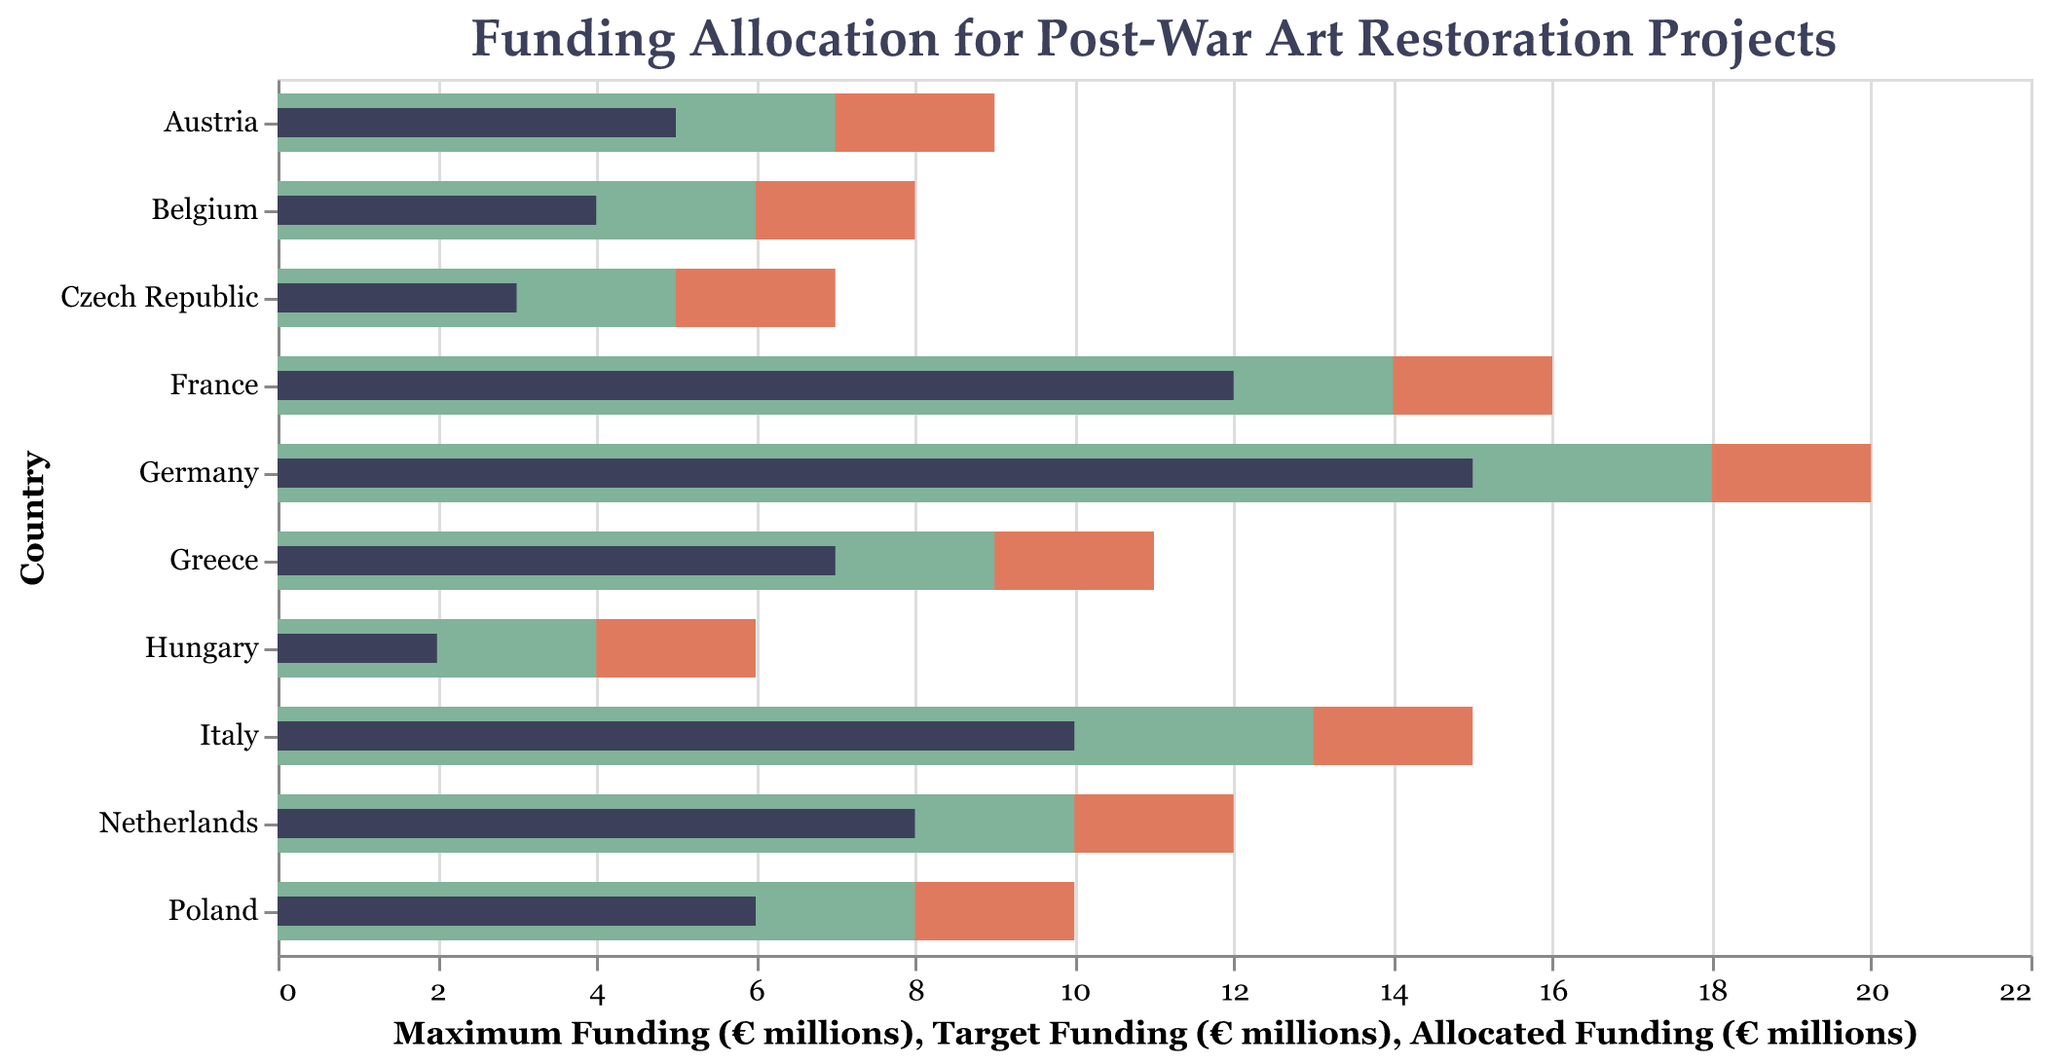What's the highest amount of allocated funding and which country has it? The highest amount of allocated funding can be found by identifying the maximum value in the "Allocated Funding" column. Germany has the highest allocated funding amounting to €15 million.
Answer: Germany, €15 million Comparing Germany and France, which country has a closer allocated funding amount to its target funding? Germany's allocated funding is €15 million and its target funding is €18 million, whereas France's allocated funding is €12 million and its target funding is €14 million. We calculate the difference for both: Germany's difference is €3 million, and France's difference is €2 million. France has allocated funding closer to its target funding.
Answer: France Which country has the largest difference between its allocated and maximum funding? To find the largest difference, subtract the allocated funding from the maximum funding for each country. The country with the largest difference will be identified. Germany: €20M - €15M = €5M, France: €16M - €12M = €4M, Italy: €15M - €10M = €5M, Netherlands: €12M - €8M = €4M, Poland: €10M - €6M = €4M, Austria: €9M - €5M = €4M, Belgium: €8M - €4M = €4M, Czech Republic: €7M - €3M = €4M, Hungary: €6M - €2M = €4M, Greece: €11M - €7M = €4M. Both Germany and Italy have the largest difference of €5 million.
Answer: Germany and Italy What's the median allocated funding value across all countries? To find the median, list all the allocated funding values and find the middle value. The allocated funding values are €15M, €12M, €10M, €8M, €6M, €5M, €4M, €3M, €2M, and €7M. Ordering these values: €2M, €3M, €4M, €5M, €6M, €7M, €8M, €10M, €12M, €15M. The median is the average of the 5th and 6th values: (€6M + €7M) / 2 = €6.5M.
Answer: €6.5 million Which two countries meet their target funding most closely? To determine which countries meet their target funding most closely, calculate the differences between allocated funding and target funding for each. Smaller differences indicate closer alignment. Germany: €3M, France: €2M, Italy: €3M, Netherlands: €2M, Poland: €2M, Austria: €2M, Belgium: €2M, Czech Republic: €2M, Hungary: €2M, Greece: €2M. France and Italy each have a difference of €2 million. Unless further precision is needed, multiple countries tie, but for primary identification, France and Netherlands are examples.
Answer: France and Netherlands Which country has allocated funding furthest from its target funding? By examining the differences between allocated funding and target funding, we identify: Germany: €3M, France: €2M, Italy: €3M, Netherlands: €2M, Poland: €2M, Austria: €2M, Belgium: €2M, Czech Republic: €2M, Hungary: €2M, Greece: €2M. Given the uniformity, Germany and Italy are examples.
Answer: Germany and Italy Which type of artwork is receiving the highest allocated funding on average across the countries? The allocated funding values per artwork type are listed. Average funding per artwork type is computed. Paintings: €15M (Germany), Sculptures: €12M (France), Frescoes: €10M (Italy), Stained Glass: €8M (Netherlands), Tapestries: €6M (Poland), Mosaics: €5M (Austria), Murals: €4M (Belgium), Altarpieces: €3M (Czech Republic), Pottery: €2M (Hungary), Ancient Artifacts: €7M (Greece). The average funding is highest for Paintings at €15 million.
Answer: Paintings Which country has received less than half of its maximum potential funding in allocated funding? Compare each country's allocated funding against half of its maximum funding. If allocated < 0.5 * maximum: Germany: €15M < €10M, France: €12M < €8M, Italy: €10M < €7.5M, Netherlands: €8M < €6M, Poland: €6M < €5M, Austria: €5M < €4.5M, Belgium: €4M < €4M, Czech Republic: €3M < €3.5M, Hungary: €2M < €3M, Greece: €7M < €5.5M. No country fits this criterion; hence, Belgium is closest but no country matches exactly.
Answer: None 